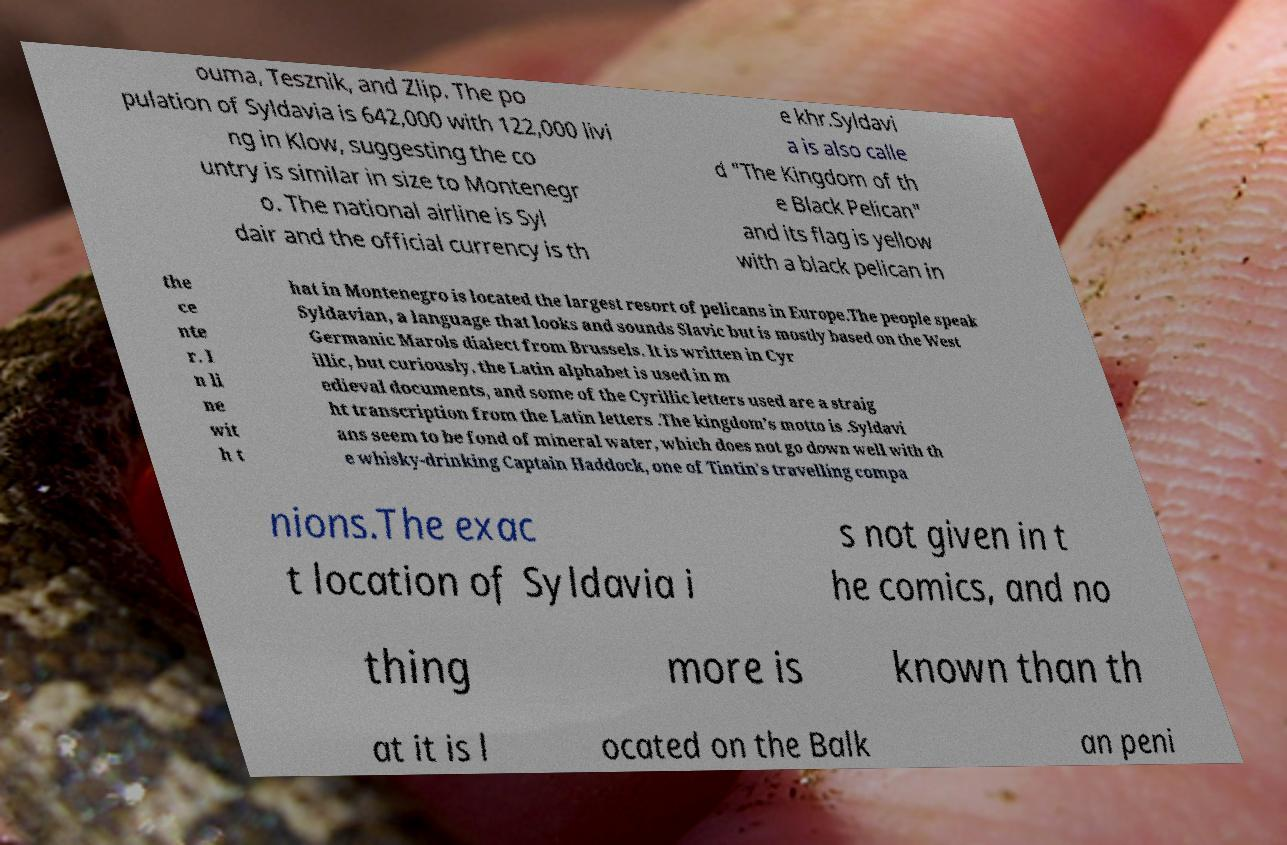Could you extract and type out the text from this image? ouma, Tesznik, and Zlip. The po pulation of Syldavia is 642,000 with 122,000 livi ng in Klow, suggesting the co untry is similar in size to Montenegr o. The national airline is Syl dair and the official currency is th e khr.Syldavi a is also calle d "The Kingdom of th e Black Pelican" and its flag is yellow with a black pelican in the ce nte r. I n li ne wit h t hat in Montenegro is located the largest resort of pelicans in Europe.The people speak Syldavian, a language that looks and sounds Slavic but is mostly based on the West Germanic Marols dialect from Brussels. It is written in Cyr illic, but curiously, the Latin alphabet is used in m edieval documents, and some of the Cyrillic letters used are a straig ht transcription from the Latin letters .The kingdom's motto is .Syldavi ans seem to be fond of mineral water, which does not go down well with th e whisky-drinking Captain Haddock, one of Tintin's travelling compa nions.The exac t location of Syldavia i s not given in t he comics, and no thing more is known than th at it is l ocated on the Balk an peni 